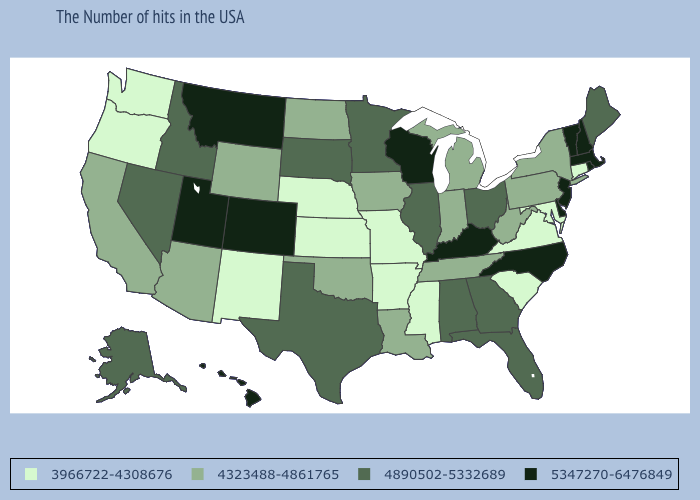What is the value of Alabama?
Write a very short answer. 4890502-5332689. What is the highest value in the USA?
Keep it brief. 5347270-6476849. What is the value of Oregon?
Give a very brief answer. 3966722-4308676. Does Rhode Island have the lowest value in the Northeast?
Give a very brief answer. No. What is the value of Michigan?
Short answer required. 4323488-4861765. What is the value of New Jersey?
Write a very short answer. 5347270-6476849. What is the value of Arkansas?
Concise answer only. 3966722-4308676. What is the lowest value in the USA?
Write a very short answer. 3966722-4308676. What is the value of Minnesota?
Keep it brief. 4890502-5332689. Among the states that border Montana , does Wyoming have the lowest value?
Give a very brief answer. Yes. Does Wisconsin have the highest value in the MidWest?
Be succinct. Yes. Which states have the lowest value in the USA?
Write a very short answer. Connecticut, Maryland, Virginia, South Carolina, Mississippi, Missouri, Arkansas, Kansas, Nebraska, New Mexico, Washington, Oregon. What is the value of Maine?
Give a very brief answer. 4890502-5332689. Name the states that have a value in the range 4890502-5332689?
Short answer required. Maine, Ohio, Florida, Georgia, Alabama, Illinois, Minnesota, Texas, South Dakota, Idaho, Nevada, Alaska. 